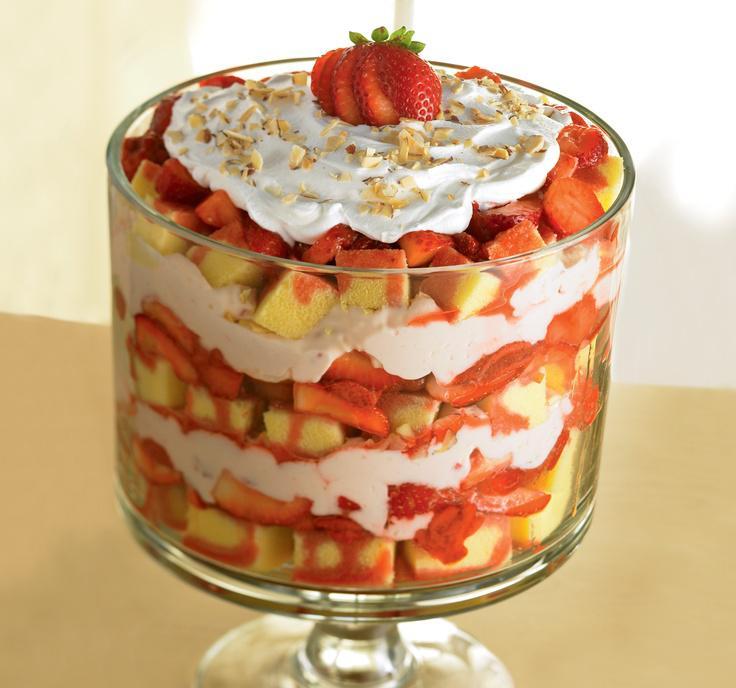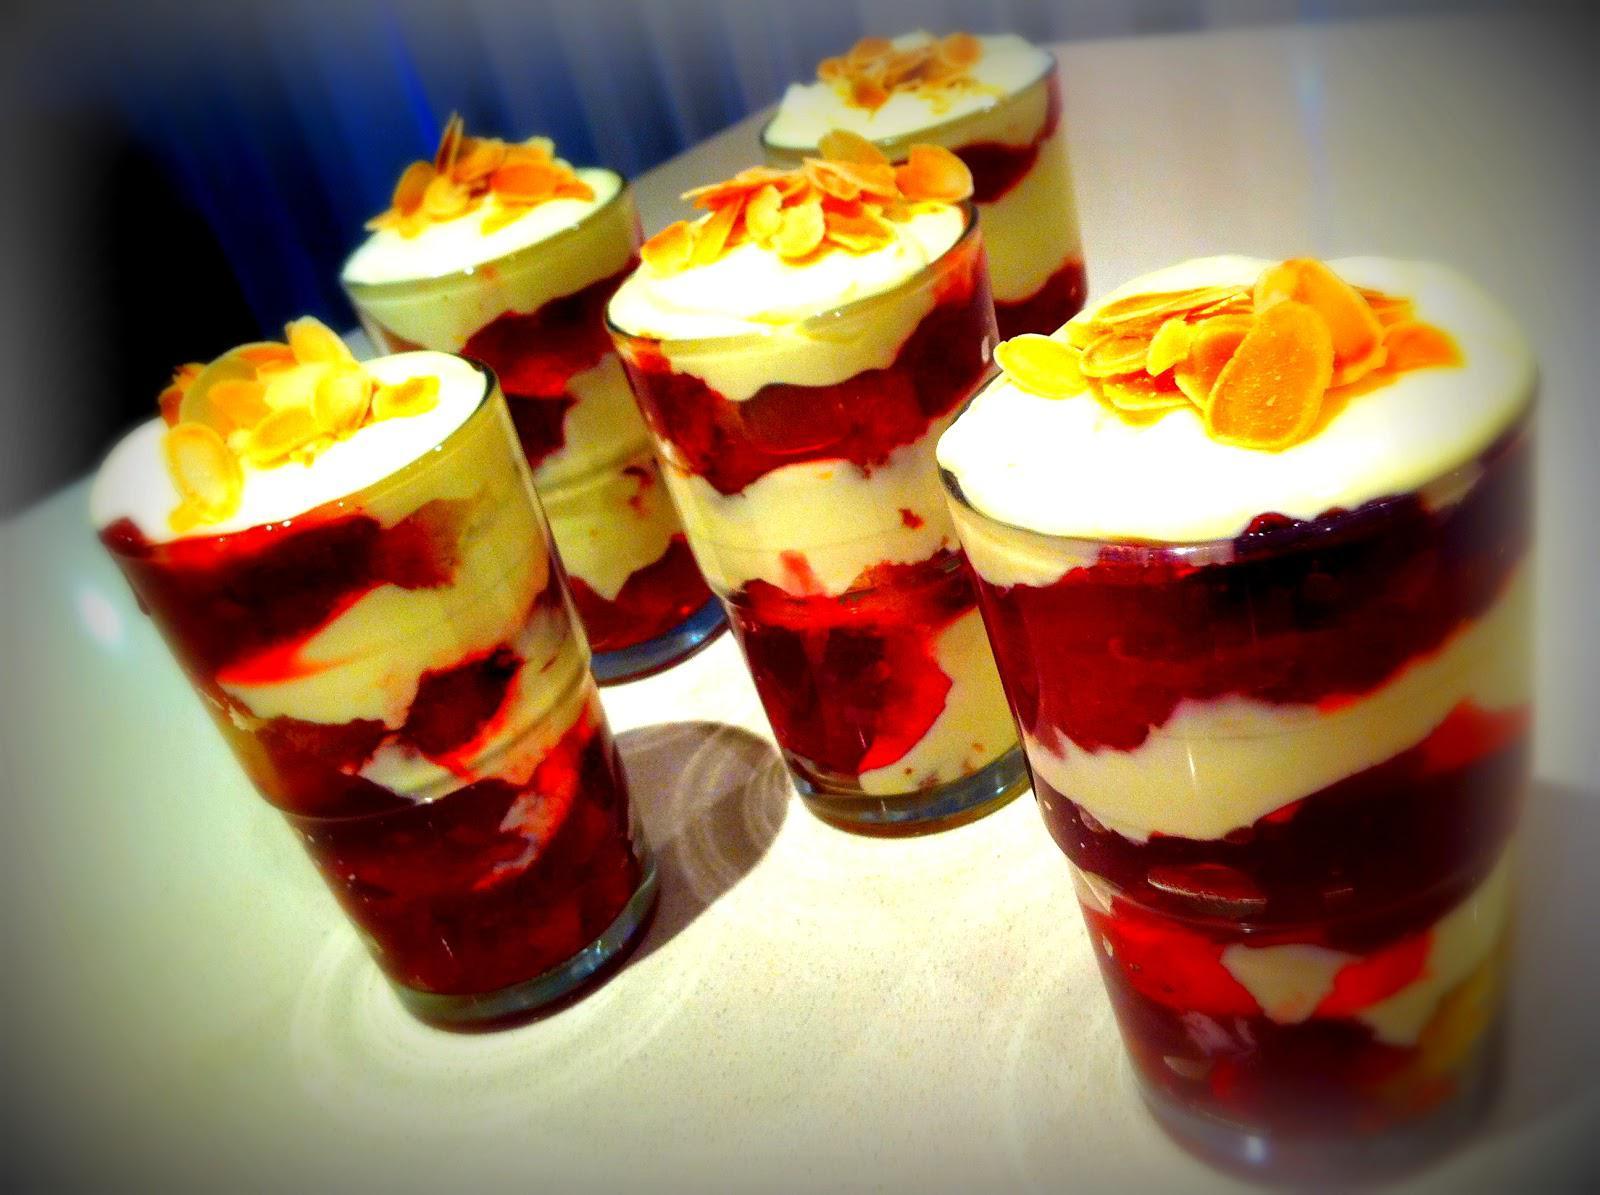The first image is the image on the left, the second image is the image on the right. Analyze the images presented: Is the assertion "Two large fancy layered desserts are in footed bowls." valid? Answer yes or no. No. The first image is the image on the left, the second image is the image on the right. Given the left and right images, does the statement "There is caramel drizzled atop the desert in the image on the left." hold true? Answer yes or no. No. 